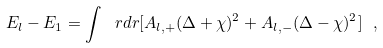Convert formula to latex. <formula><loc_0><loc_0><loc_500><loc_500>E _ { l } - E _ { 1 } = \int \ r d r [ A _ { l , + } ( \Delta + \chi ) ^ { 2 } + A _ { l , - } ( \Delta - \chi ) ^ { 2 } ] \ ,</formula> 